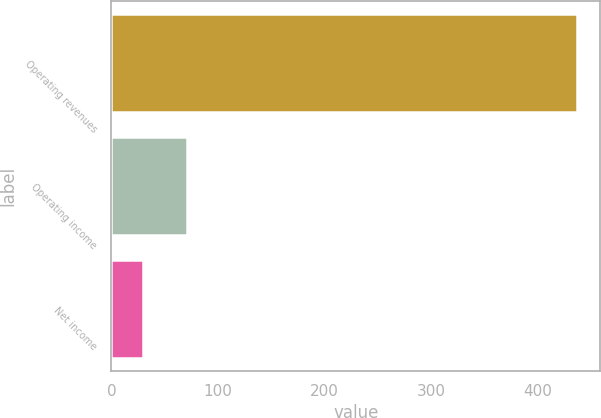Convert chart to OTSL. <chart><loc_0><loc_0><loc_500><loc_500><bar_chart><fcel>Operating revenues<fcel>Operating income<fcel>Net income<nl><fcel>437<fcel>70.7<fcel>30<nl></chart> 